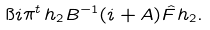<formula> <loc_0><loc_0><loc_500><loc_500>\i i \pi ^ { t } \, h _ { 2 } B ^ { - 1 } ( i + A ) \hat { F } h _ { 2 } .</formula> 